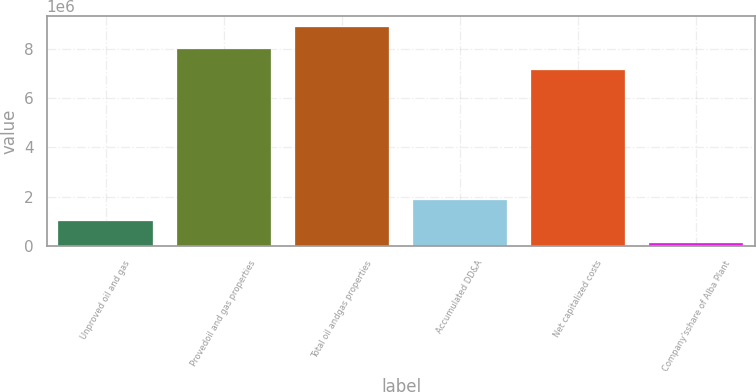Convert chart to OTSL. <chart><loc_0><loc_0><loc_500><loc_500><bar_chart><fcel>Unproved oil and gas<fcel>Provedoil and gas properties<fcel>Total oil andgas properties<fcel>Accumulated DD&A<fcel>Net capitalized costs<fcel>Company'sshare of Alba Plant<nl><fcel>997906<fcel>8.007e+06<fcel>8.88045e+06<fcel>1.87136e+06<fcel>7.13354e+06<fcel>124454<nl></chart> 